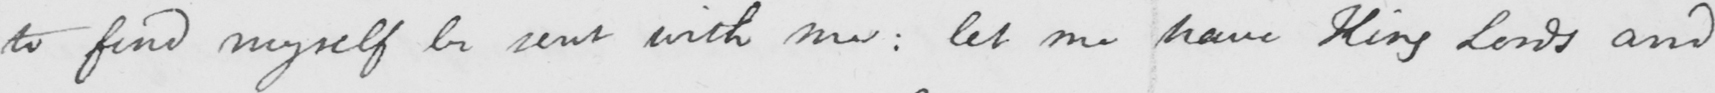What does this handwritten line say? to find myself be sent with me :  let me have King Lords and 